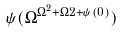<formula> <loc_0><loc_0><loc_500><loc_500>\psi ( \Omega ^ { \Omega ^ { 2 } + \Omega 2 + \psi ( 0 ) } )</formula> 